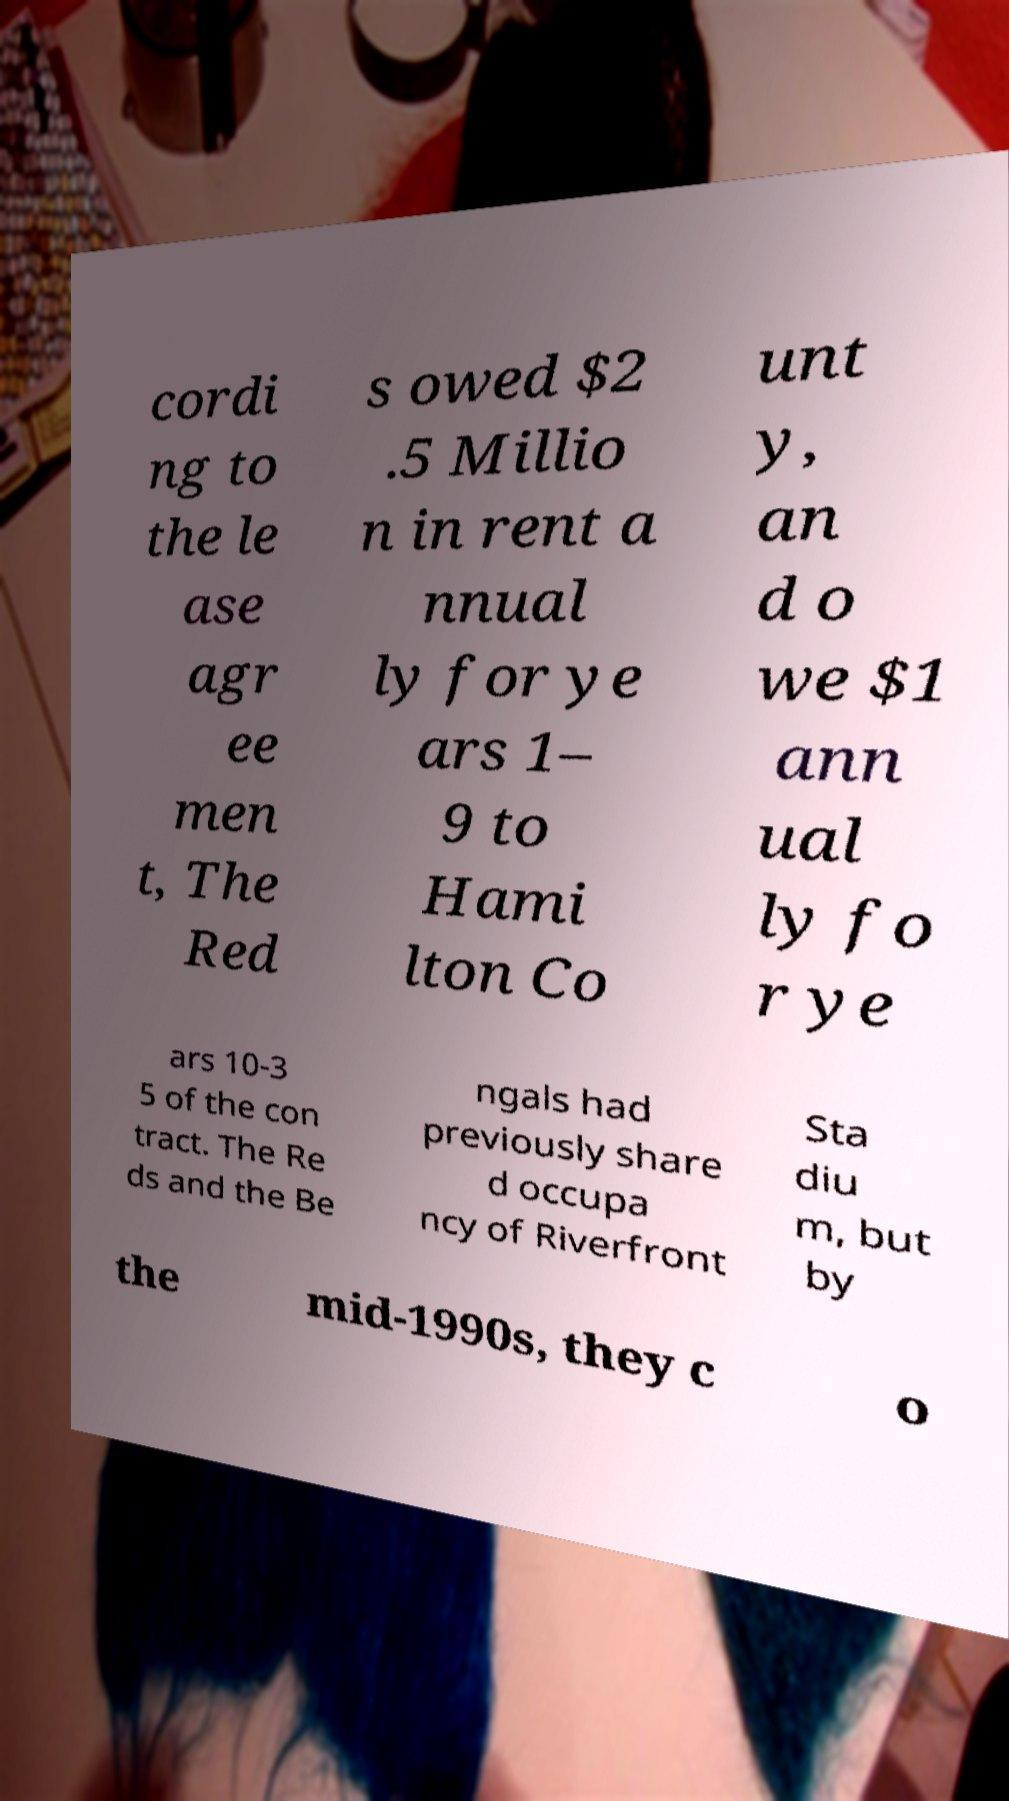Please identify and transcribe the text found in this image. cordi ng to the le ase agr ee men t, The Red s owed $2 .5 Millio n in rent a nnual ly for ye ars 1– 9 to Hami lton Co unt y, an d o we $1 ann ual ly fo r ye ars 10-3 5 of the con tract. The Re ds and the Be ngals had previously share d occupa ncy of Riverfront Sta diu m, but by the mid-1990s, they c o 